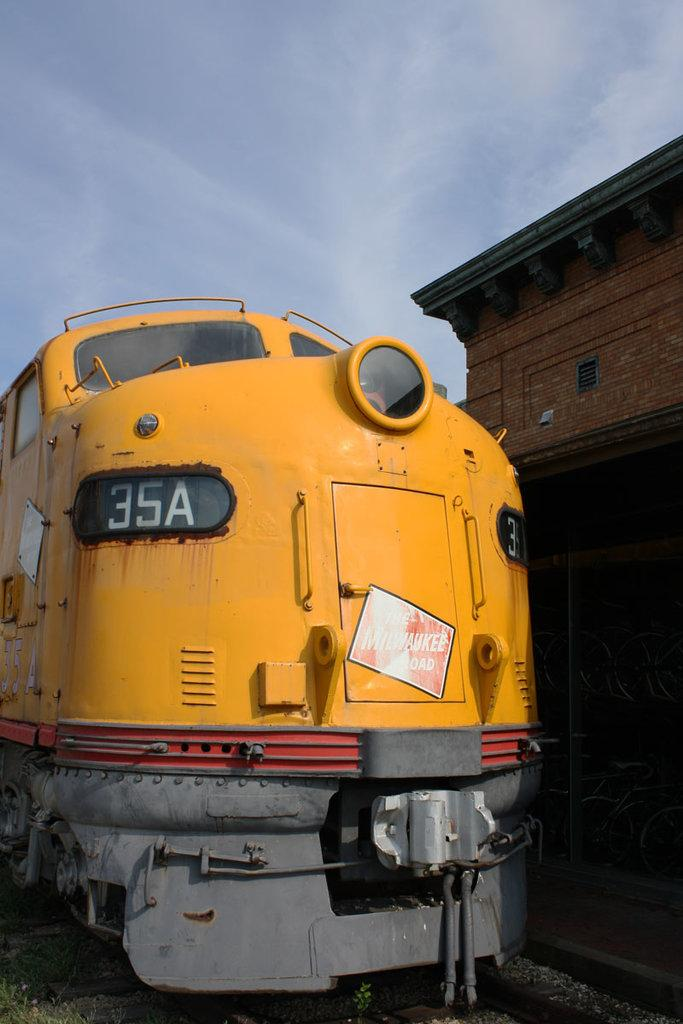Provide a one-sentence caption for the provided image. an old, slightly rusty train has a window with the numbers 35A in it. 